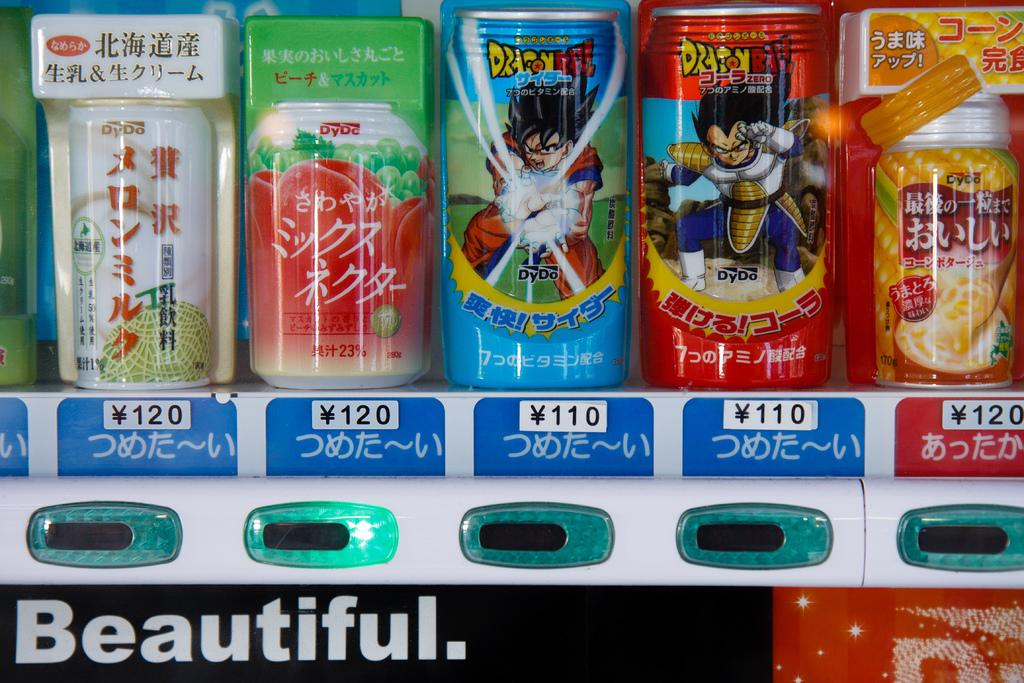What type of containers are visible in the image? There are beverage tins in the image. Can you describe the contents of the tins? The contents of the tins are not visible in the image, but they are likely beverages. Are there any other objects or items visible in the image? The provided facts do not mention any other objects or items in the image. Who won the competition involving the beverage tins in the image? There is no competition involving the beverage tins in the image, so it is not possible to determine a winner. 